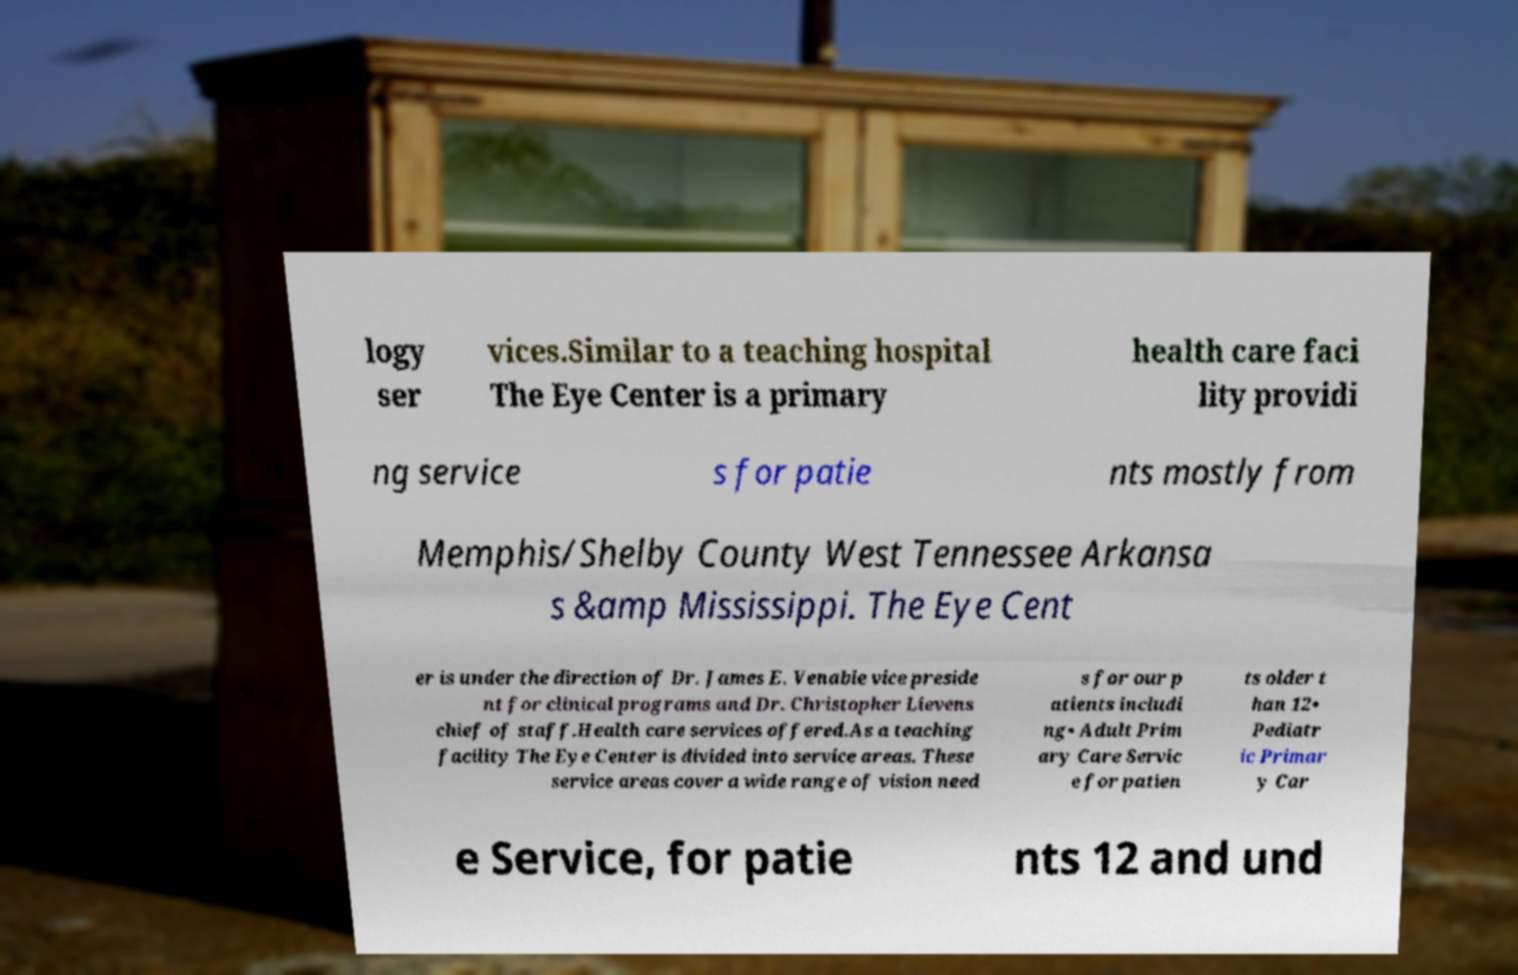There's text embedded in this image that I need extracted. Can you transcribe it verbatim? logy ser vices.Similar to a teaching hospital The Eye Center is a primary health care faci lity providi ng service s for patie nts mostly from Memphis/Shelby County West Tennessee Arkansa s &amp Mississippi. The Eye Cent er is under the direction of Dr. James E. Venable vice preside nt for clinical programs and Dr. Christopher Lievens chief of staff.Health care services offered.As a teaching facility The Eye Center is divided into service areas. These service areas cover a wide range of vision need s for our p atients includi ng• Adult Prim ary Care Servic e for patien ts older t han 12• Pediatr ic Primar y Car e Service, for patie nts 12 and und 